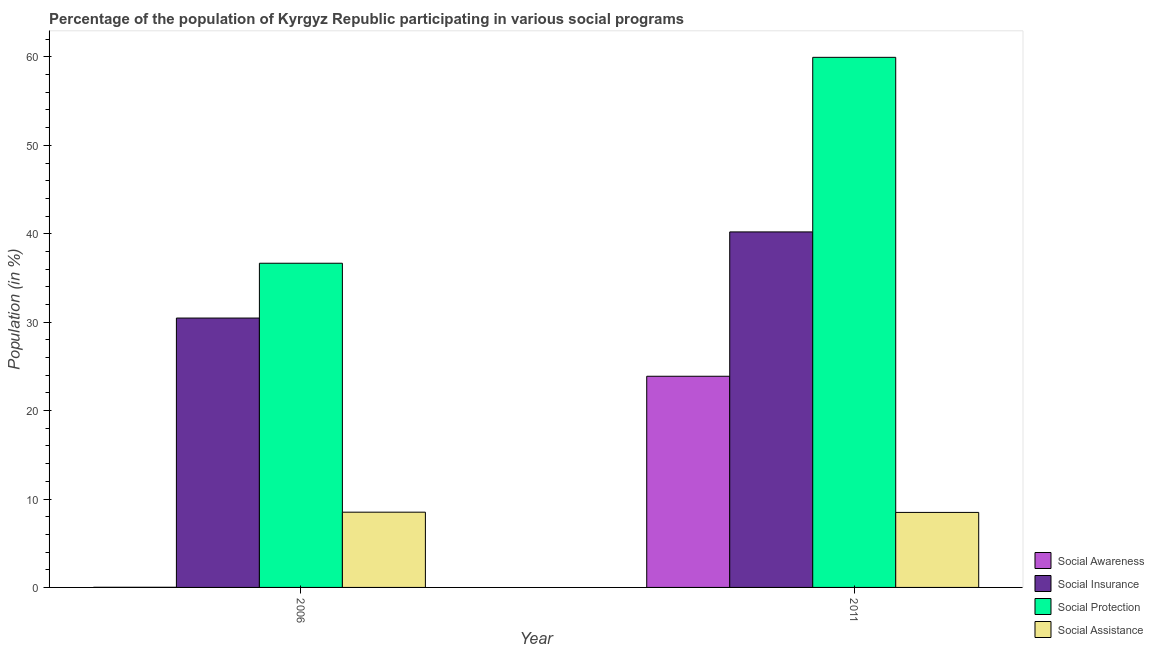How many different coloured bars are there?
Provide a short and direct response. 4. How many groups of bars are there?
Your answer should be very brief. 2. Are the number of bars on each tick of the X-axis equal?
Your response must be concise. Yes. How many bars are there on the 1st tick from the left?
Your answer should be compact. 4. How many bars are there on the 1st tick from the right?
Offer a terse response. 4. In how many cases, is the number of bars for a given year not equal to the number of legend labels?
Make the answer very short. 0. What is the participation of population in social insurance programs in 2011?
Your response must be concise. 40.21. Across all years, what is the maximum participation of population in social protection programs?
Keep it short and to the point. 59.95. Across all years, what is the minimum participation of population in social awareness programs?
Give a very brief answer. 0.02. In which year was the participation of population in social insurance programs maximum?
Provide a succinct answer. 2011. In which year was the participation of population in social insurance programs minimum?
Offer a terse response. 2006. What is the total participation of population in social insurance programs in the graph?
Give a very brief answer. 70.67. What is the difference between the participation of population in social assistance programs in 2006 and that in 2011?
Your response must be concise. 0.03. What is the difference between the participation of population in social assistance programs in 2011 and the participation of population in social insurance programs in 2006?
Keep it short and to the point. -0.03. What is the average participation of population in social protection programs per year?
Your answer should be very brief. 48.31. In how many years, is the participation of population in social assistance programs greater than 44 %?
Your response must be concise. 0. What is the ratio of the participation of population in social insurance programs in 2006 to that in 2011?
Provide a succinct answer. 0.76. In how many years, is the participation of population in social protection programs greater than the average participation of population in social protection programs taken over all years?
Your answer should be very brief. 1. What does the 3rd bar from the left in 2006 represents?
Provide a succinct answer. Social Protection. What does the 3rd bar from the right in 2006 represents?
Offer a very short reply. Social Insurance. Is it the case that in every year, the sum of the participation of population in social awareness programs and participation of population in social insurance programs is greater than the participation of population in social protection programs?
Your answer should be very brief. No. How many bars are there?
Keep it short and to the point. 8. What is the difference between two consecutive major ticks on the Y-axis?
Offer a terse response. 10. Are the values on the major ticks of Y-axis written in scientific E-notation?
Make the answer very short. No. How are the legend labels stacked?
Your answer should be very brief. Vertical. What is the title of the graph?
Offer a terse response. Percentage of the population of Kyrgyz Republic participating in various social programs . What is the Population (in %) of Social Awareness in 2006?
Provide a succinct answer. 0.02. What is the Population (in %) of Social Insurance in 2006?
Provide a succinct answer. 30.47. What is the Population (in %) in Social Protection in 2006?
Give a very brief answer. 36.66. What is the Population (in %) in Social Assistance in 2006?
Keep it short and to the point. 8.51. What is the Population (in %) of Social Awareness in 2011?
Your answer should be very brief. 23.88. What is the Population (in %) in Social Insurance in 2011?
Provide a succinct answer. 40.21. What is the Population (in %) of Social Protection in 2011?
Your answer should be very brief. 59.95. What is the Population (in %) in Social Assistance in 2011?
Give a very brief answer. 8.48. Across all years, what is the maximum Population (in %) in Social Awareness?
Keep it short and to the point. 23.88. Across all years, what is the maximum Population (in %) in Social Insurance?
Your answer should be very brief. 40.21. Across all years, what is the maximum Population (in %) in Social Protection?
Provide a succinct answer. 59.95. Across all years, what is the maximum Population (in %) of Social Assistance?
Your answer should be compact. 8.51. Across all years, what is the minimum Population (in %) in Social Awareness?
Provide a short and direct response. 0.02. Across all years, what is the minimum Population (in %) of Social Insurance?
Your answer should be very brief. 30.47. Across all years, what is the minimum Population (in %) of Social Protection?
Offer a terse response. 36.66. Across all years, what is the minimum Population (in %) of Social Assistance?
Ensure brevity in your answer.  8.48. What is the total Population (in %) of Social Awareness in the graph?
Your response must be concise. 23.9. What is the total Population (in %) in Social Insurance in the graph?
Your response must be concise. 70.67. What is the total Population (in %) in Social Protection in the graph?
Keep it short and to the point. 96.62. What is the total Population (in %) in Social Assistance in the graph?
Give a very brief answer. 16.99. What is the difference between the Population (in %) in Social Awareness in 2006 and that in 2011?
Provide a short and direct response. -23.87. What is the difference between the Population (in %) of Social Insurance in 2006 and that in 2011?
Offer a very short reply. -9.74. What is the difference between the Population (in %) of Social Protection in 2006 and that in 2011?
Your response must be concise. -23.29. What is the difference between the Population (in %) of Social Assistance in 2006 and that in 2011?
Give a very brief answer. 0.03. What is the difference between the Population (in %) in Social Awareness in 2006 and the Population (in %) in Social Insurance in 2011?
Provide a short and direct response. -40.19. What is the difference between the Population (in %) in Social Awareness in 2006 and the Population (in %) in Social Protection in 2011?
Make the answer very short. -59.94. What is the difference between the Population (in %) in Social Awareness in 2006 and the Population (in %) in Social Assistance in 2011?
Your response must be concise. -8.47. What is the difference between the Population (in %) of Social Insurance in 2006 and the Population (in %) of Social Protection in 2011?
Keep it short and to the point. -29.49. What is the difference between the Population (in %) in Social Insurance in 2006 and the Population (in %) in Social Assistance in 2011?
Your response must be concise. 21.98. What is the difference between the Population (in %) in Social Protection in 2006 and the Population (in %) in Social Assistance in 2011?
Your answer should be very brief. 28.18. What is the average Population (in %) in Social Awareness per year?
Give a very brief answer. 11.95. What is the average Population (in %) of Social Insurance per year?
Keep it short and to the point. 35.34. What is the average Population (in %) of Social Protection per year?
Provide a short and direct response. 48.31. What is the average Population (in %) in Social Assistance per year?
Your answer should be compact. 8.5. In the year 2006, what is the difference between the Population (in %) of Social Awareness and Population (in %) of Social Insurance?
Provide a short and direct response. -30.45. In the year 2006, what is the difference between the Population (in %) of Social Awareness and Population (in %) of Social Protection?
Your answer should be compact. -36.65. In the year 2006, what is the difference between the Population (in %) in Social Awareness and Population (in %) in Social Assistance?
Provide a succinct answer. -8.5. In the year 2006, what is the difference between the Population (in %) of Social Insurance and Population (in %) of Social Protection?
Offer a terse response. -6.2. In the year 2006, what is the difference between the Population (in %) in Social Insurance and Population (in %) in Social Assistance?
Your response must be concise. 21.96. In the year 2006, what is the difference between the Population (in %) of Social Protection and Population (in %) of Social Assistance?
Make the answer very short. 28.15. In the year 2011, what is the difference between the Population (in %) in Social Awareness and Population (in %) in Social Insurance?
Your answer should be very brief. -16.33. In the year 2011, what is the difference between the Population (in %) in Social Awareness and Population (in %) in Social Protection?
Provide a short and direct response. -36.07. In the year 2011, what is the difference between the Population (in %) of Social Awareness and Population (in %) of Social Assistance?
Your response must be concise. 15.4. In the year 2011, what is the difference between the Population (in %) in Social Insurance and Population (in %) in Social Protection?
Provide a short and direct response. -19.75. In the year 2011, what is the difference between the Population (in %) of Social Insurance and Population (in %) of Social Assistance?
Offer a very short reply. 31.73. In the year 2011, what is the difference between the Population (in %) in Social Protection and Population (in %) in Social Assistance?
Provide a succinct answer. 51.47. What is the ratio of the Population (in %) in Social Awareness in 2006 to that in 2011?
Ensure brevity in your answer.  0. What is the ratio of the Population (in %) of Social Insurance in 2006 to that in 2011?
Give a very brief answer. 0.76. What is the ratio of the Population (in %) in Social Protection in 2006 to that in 2011?
Provide a short and direct response. 0.61. What is the ratio of the Population (in %) in Social Assistance in 2006 to that in 2011?
Provide a succinct answer. 1. What is the difference between the highest and the second highest Population (in %) of Social Awareness?
Ensure brevity in your answer.  23.87. What is the difference between the highest and the second highest Population (in %) in Social Insurance?
Make the answer very short. 9.74. What is the difference between the highest and the second highest Population (in %) in Social Protection?
Your answer should be very brief. 23.29. What is the difference between the highest and the second highest Population (in %) of Social Assistance?
Your answer should be compact. 0.03. What is the difference between the highest and the lowest Population (in %) of Social Awareness?
Your response must be concise. 23.87. What is the difference between the highest and the lowest Population (in %) in Social Insurance?
Your response must be concise. 9.74. What is the difference between the highest and the lowest Population (in %) in Social Protection?
Make the answer very short. 23.29. What is the difference between the highest and the lowest Population (in %) in Social Assistance?
Your response must be concise. 0.03. 